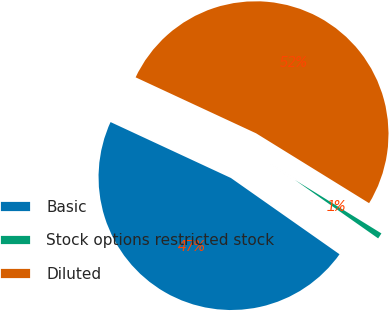<chart> <loc_0><loc_0><loc_500><loc_500><pie_chart><fcel>Basic<fcel>Stock options restricted stock<fcel>Diluted<nl><fcel>47.18%<fcel>0.93%<fcel>51.89%<nl></chart> 